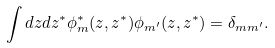Convert formula to latex. <formula><loc_0><loc_0><loc_500><loc_500>\int d z d z ^ { * } \phi _ { m } ^ { * } ( z , z ^ { * } ) \phi _ { m ^ { \prime } } ( z , z ^ { * } ) = \delta _ { m m ^ { \prime } } .</formula> 